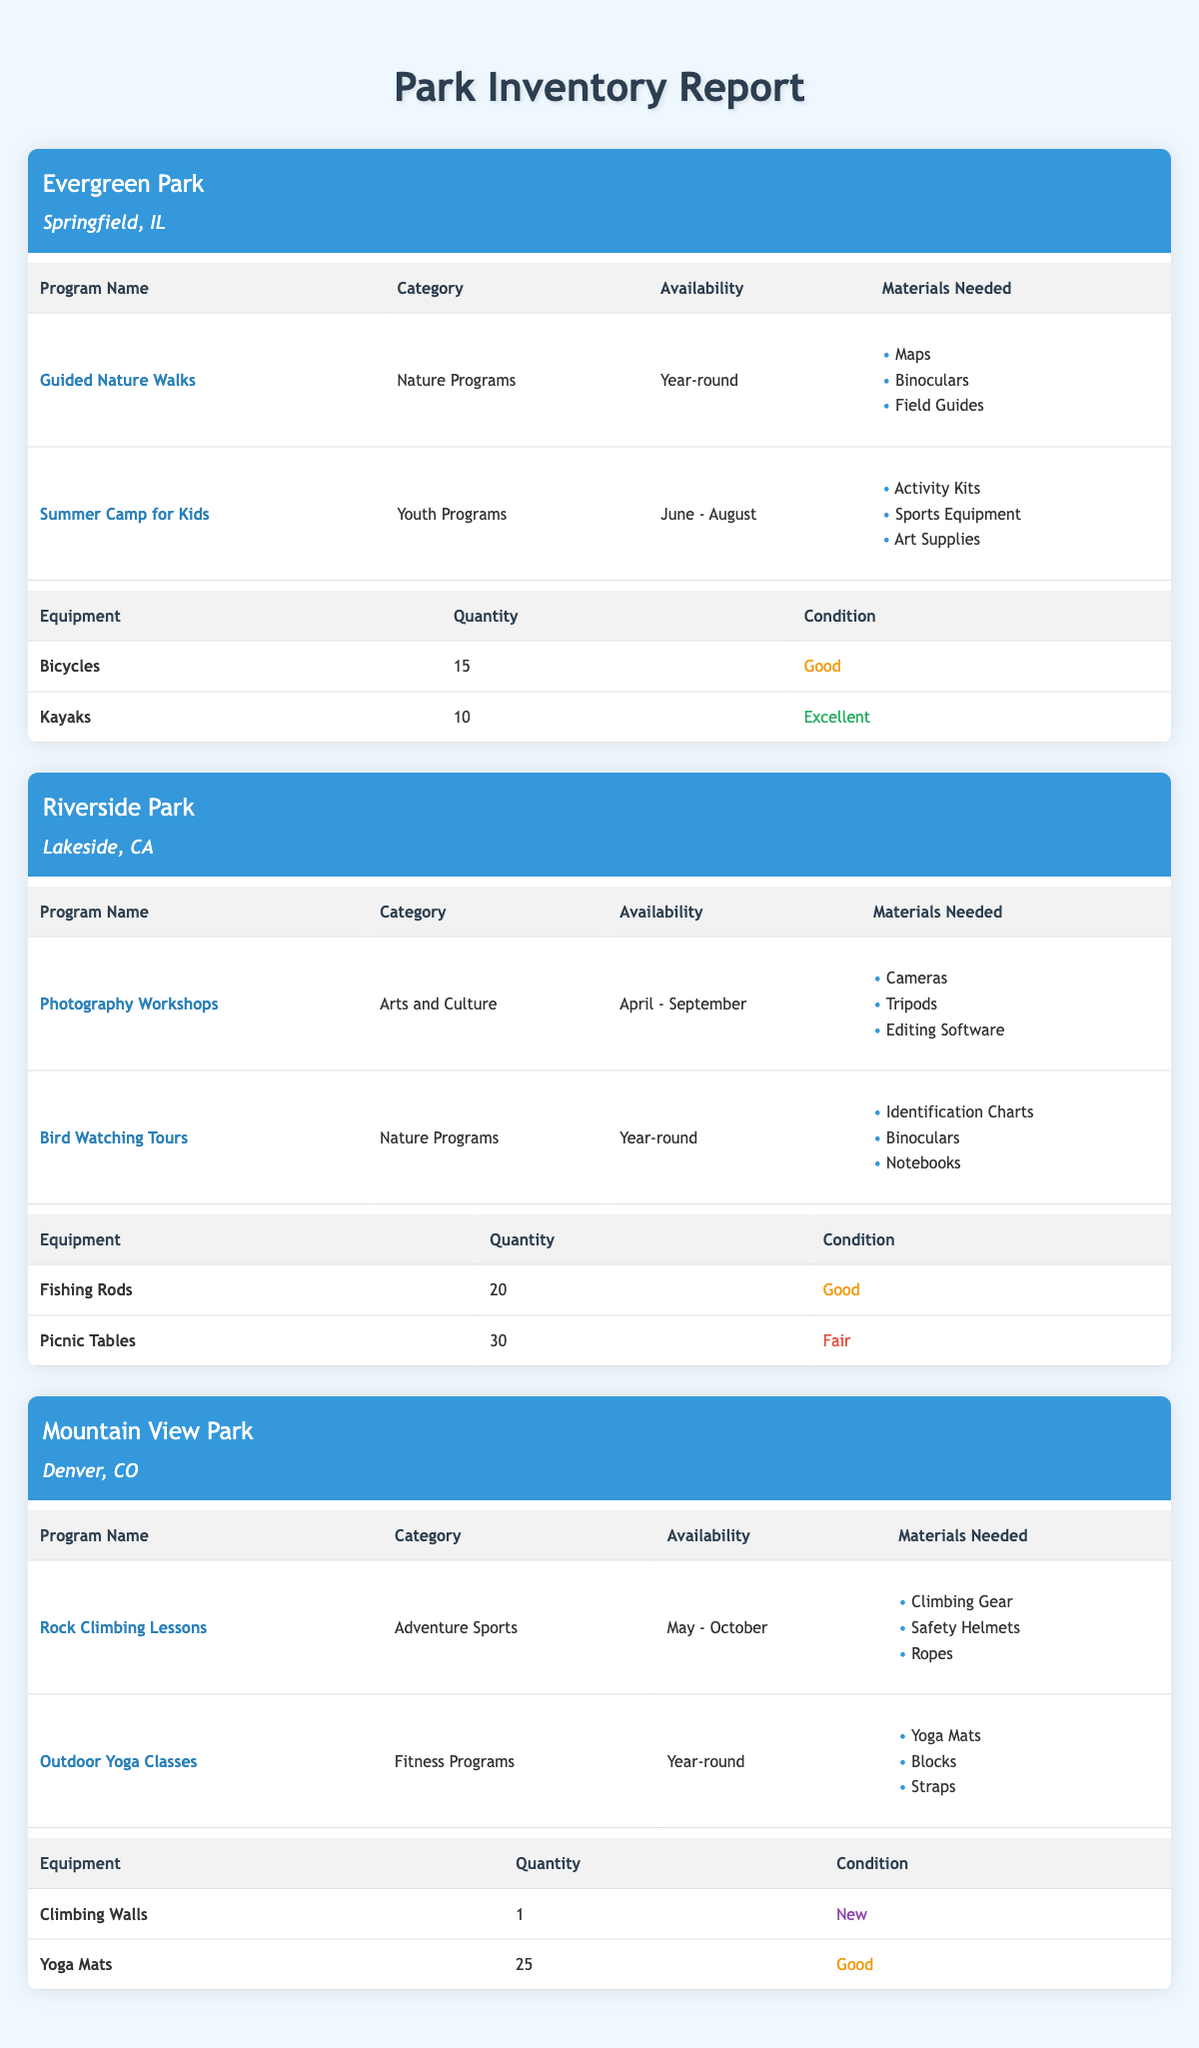What recreational program is available year-round at Evergreen Park? From the table, we can see that Evergreen Park has two programs listed. The first, "Guided Nature Walks," specifies that it is available year-round. The second program, "Summer Camp for Kids," is only available from June to August. Therefore, the only program that is available year-round at Evergreen Park is "Guided Nature Walks."
Answer: Guided Nature Walks How many equipment items are listed for Riverside Park? By examining the table, Riverside Park has two equipment items listed: "Fishing Rods" and "Picnic Tables." Thus, the total count of equipment items is 2.
Answer: 2 What materials are needed for the Rock Climbing Lessons at Mountain View Park? The table indicates that the Rock Climbing Lessons at Mountain View Park require three materials: "Climbing Gear," "Safety Helmets," and "Ropes." Therefore, those are the materials needed for this program.
Answer: Climbing Gear, Safety Helmets, Ropes Does Mountain View Park have any equipment in new condition? The equipment inventory for Mountain View Park includes "Climbing Walls" with a condition marked as new. Therefore, the answer to this question is yes.
Answer: Yes Which park has the highest quantity of equipment available, and what is that item? First, we will look at the total quantities of equipment for each park. Evergreen Park has 15 bicycles and 10 kayaks (total 25), Riverside Park has 20 fishing rods and 30 picnic tables (total 50), and Mountain View Park has 1 climbing wall and 25 yoga mats (total 26). Comparing these totals, Riverside Park has the highest quantity of equipment, specifically "Picnic Tables," with a quantity of 30.
Answer: Riverside Park, Picnic Tables What is the total quantity of equipment available at all parks combined? We will calculate the total equipment quantity by adding the quantities from each park. Evergreen Park has 25 items (15 + 10), Riverside Park has 50 items (20 + 30), and Mountain View Park has 26 items (1 + 25). So, the total quantity is 25 + 50 + 26 = 101.
Answer: 101 